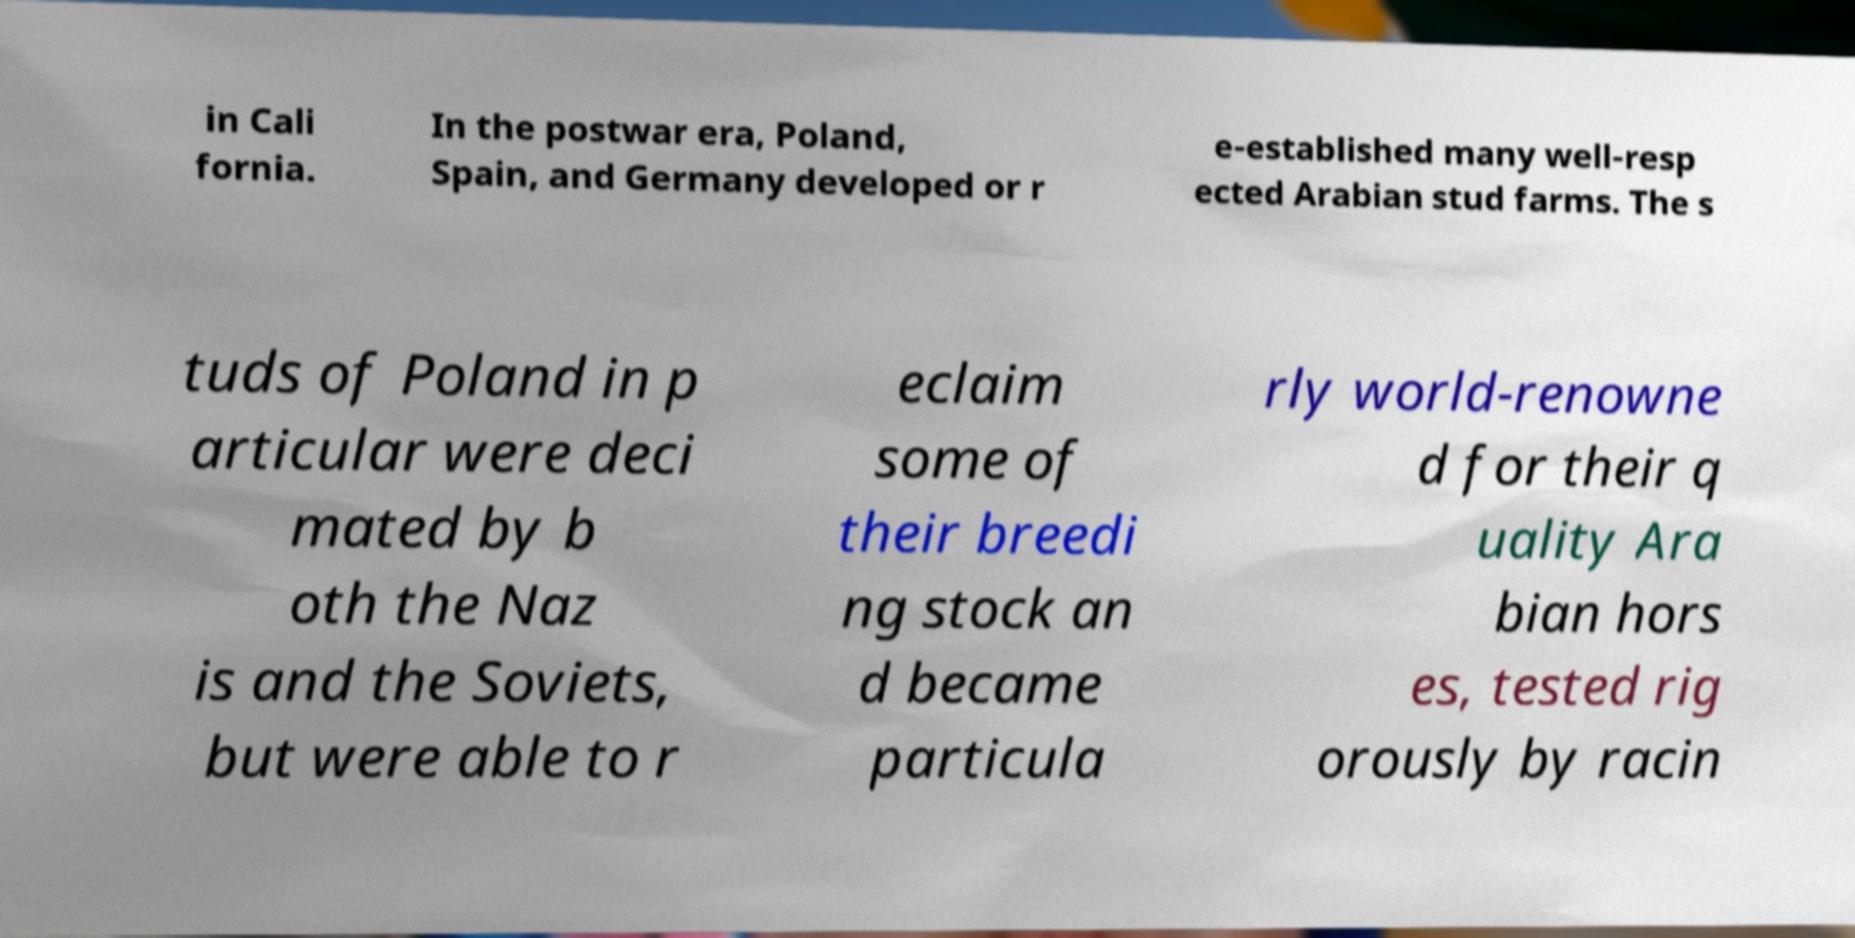Can you accurately transcribe the text from the provided image for me? in Cali fornia. In the postwar era, Poland, Spain, and Germany developed or r e-established many well-resp ected Arabian stud farms. The s tuds of Poland in p articular were deci mated by b oth the Naz is and the Soviets, but were able to r eclaim some of their breedi ng stock an d became particula rly world-renowne d for their q uality Ara bian hors es, tested rig orously by racin 